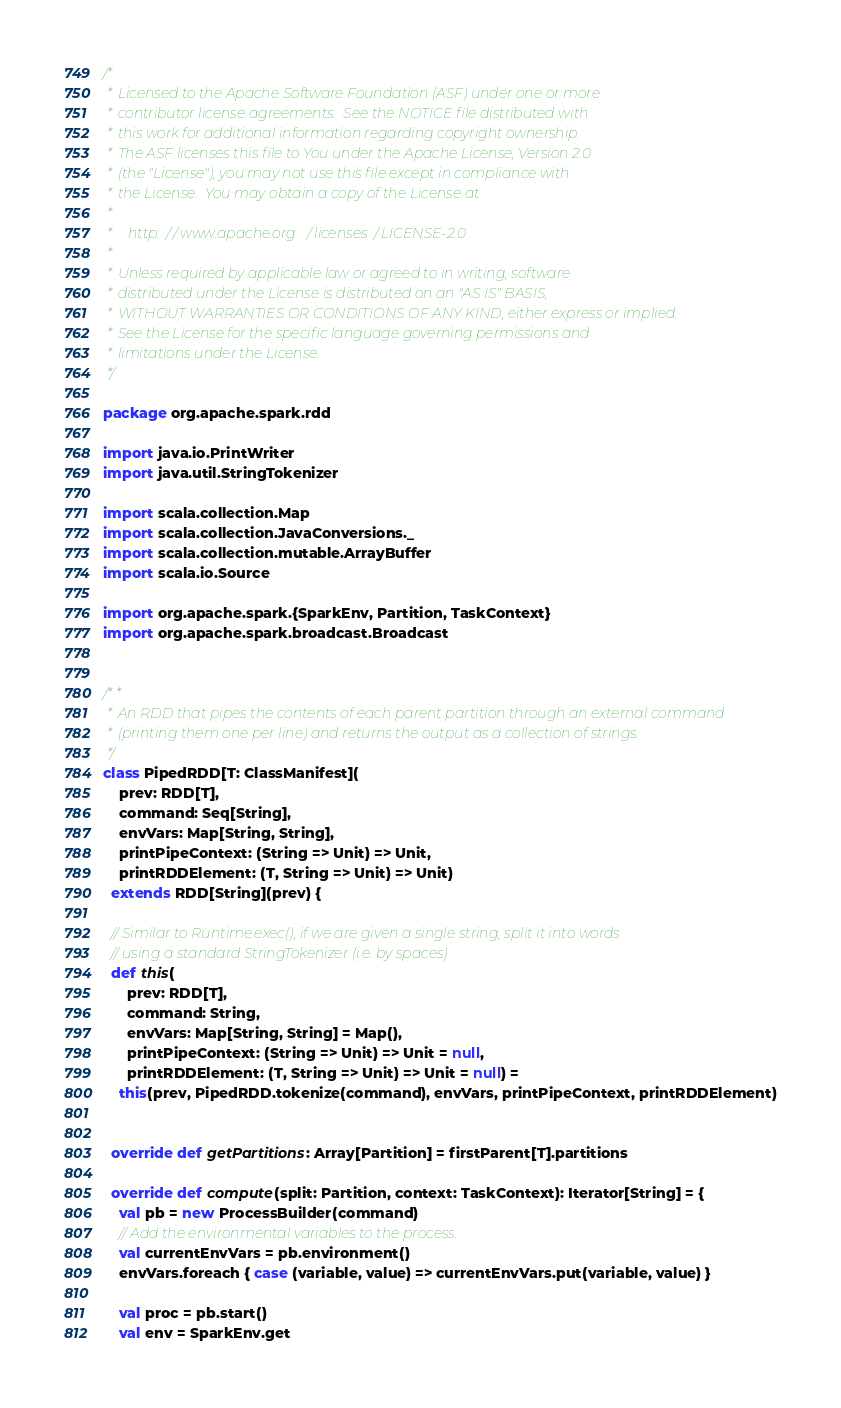<code> <loc_0><loc_0><loc_500><loc_500><_Scala_>/*
 * Licensed to the Apache Software Foundation (ASF) under one or more
 * contributor license agreements.  See the NOTICE file distributed with
 * this work for additional information regarding copyright ownership.
 * The ASF licenses this file to You under the Apache License, Version 2.0
 * (the "License"); you may not use this file except in compliance with
 * the License.  You may obtain a copy of the License at
 *
 *    http://www.apache.org/licenses/LICENSE-2.0
 *
 * Unless required by applicable law or agreed to in writing, software
 * distributed under the License is distributed on an "AS IS" BASIS,
 * WITHOUT WARRANTIES OR CONDITIONS OF ANY KIND, either express or implied.
 * See the License for the specific language governing permissions and
 * limitations under the License.
 */

package org.apache.spark.rdd

import java.io.PrintWriter
import java.util.StringTokenizer

import scala.collection.Map
import scala.collection.JavaConversions._
import scala.collection.mutable.ArrayBuffer
import scala.io.Source

import org.apache.spark.{SparkEnv, Partition, TaskContext}
import org.apache.spark.broadcast.Broadcast


/**
 * An RDD that pipes the contents of each parent partition through an external command
 * (printing them one per line) and returns the output as a collection of strings.
 */
class PipedRDD[T: ClassManifest](
    prev: RDD[T],
    command: Seq[String],
    envVars: Map[String, String],
    printPipeContext: (String => Unit) => Unit,
    printRDDElement: (T, String => Unit) => Unit)
  extends RDD[String](prev) {

  // Similar to Runtime.exec(), if we are given a single string, split it into words
  // using a standard StringTokenizer (i.e. by spaces)
  def this(
      prev: RDD[T],
      command: String,
      envVars: Map[String, String] = Map(),
      printPipeContext: (String => Unit) => Unit = null,
      printRDDElement: (T, String => Unit) => Unit = null) =
    this(prev, PipedRDD.tokenize(command), envVars, printPipeContext, printRDDElement)


  override def getPartitions: Array[Partition] = firstParent[T].partitions

  override def compute(split: Partition, context: TaskContext): Iterator[String] = {
    val pb = new ProcessBuilder(command)
    // Add the environmental variables to the process.
    val currentEnvVars = pb.environment()
    envVars.foreach { case (variable, value) => currentEnvVars.put(variable, value) }

    val proc = pb.start()
    val env = SparkEnv.get
</code> 